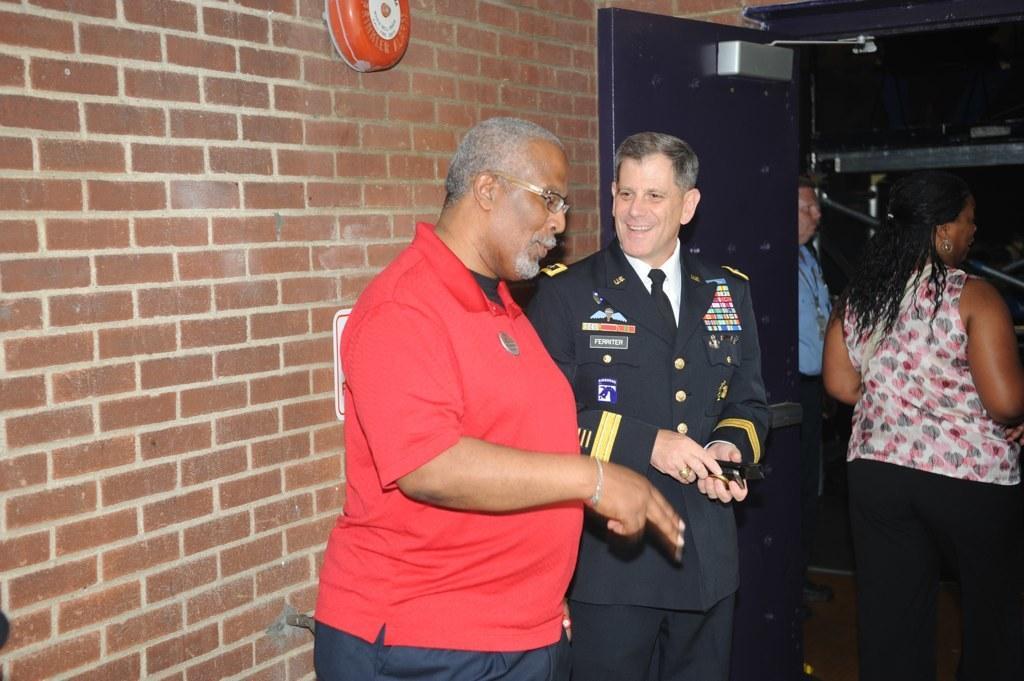Describe this image in one or two sentences. On the left side, there is an object on the brick wall. In the middle, there are two persons in different color dresses, smiling and standing. On the right side, there is a woman standing. In the background, there is a person and violet color door. 